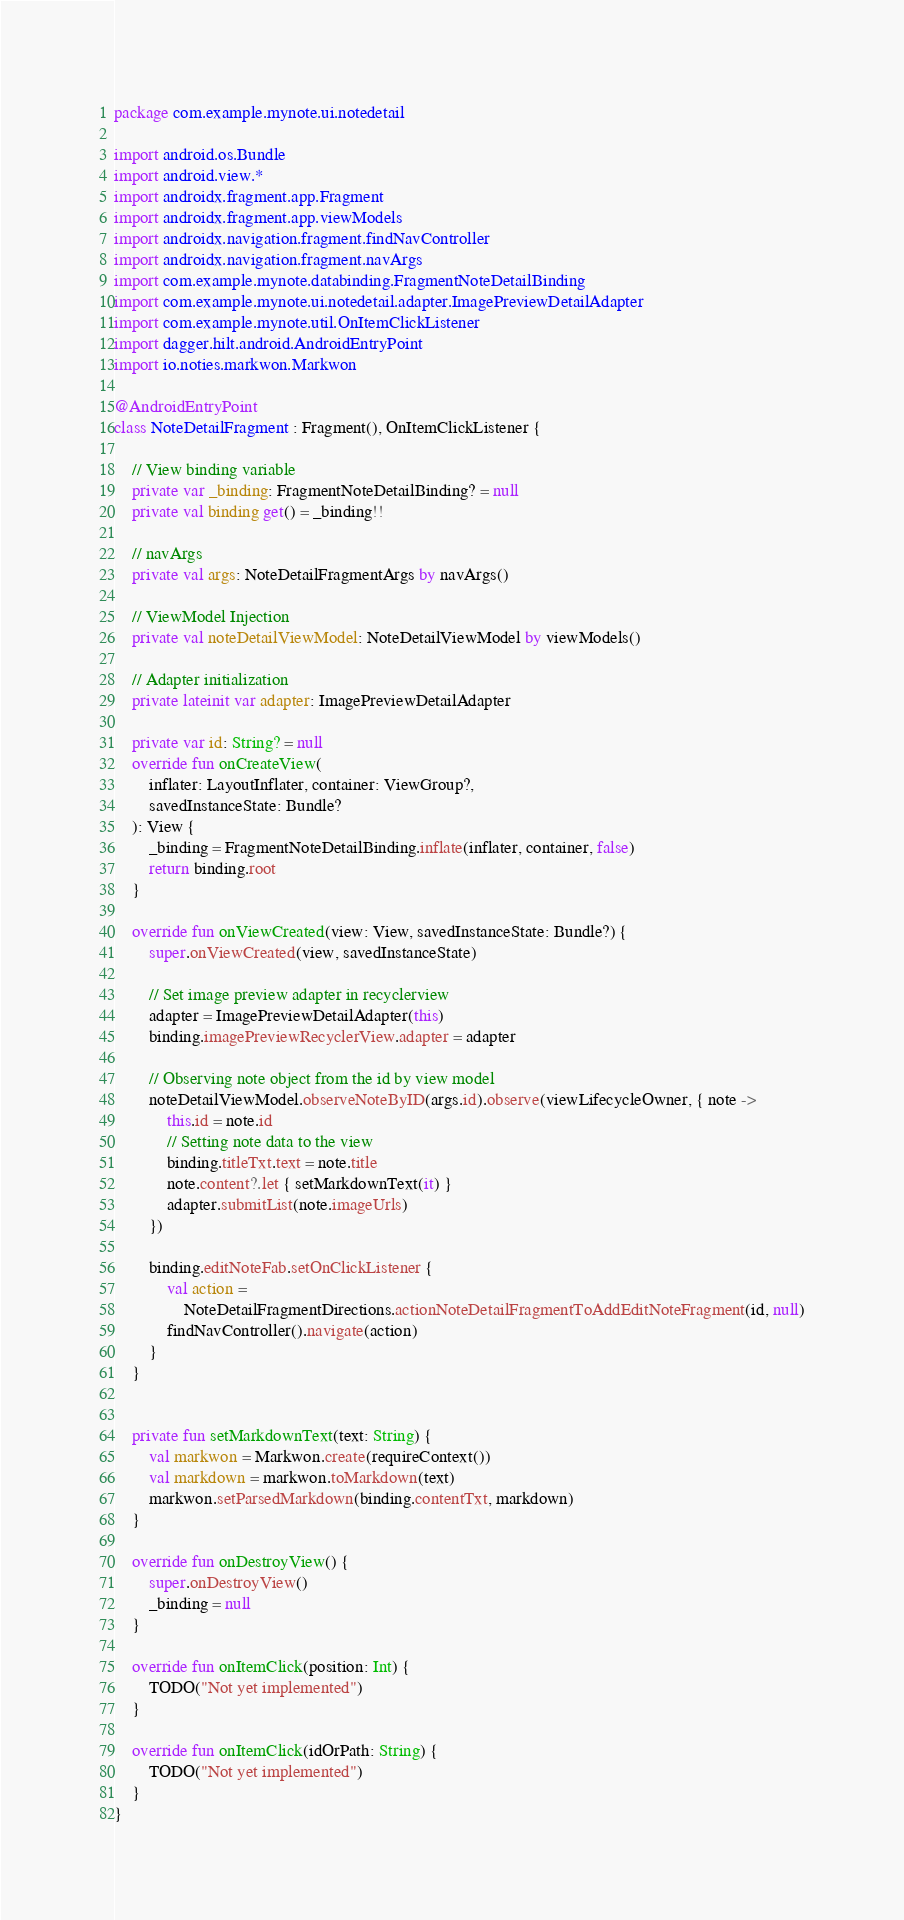<code> <loc_0><loc_0><loc_500><loc_500><_Kotlin_>package com.example.mynote.ui.notedetail

import android.os.Bundle
import android.view.*
import androidx.fragment.app.Fragment
import androidx.fragment.app.viewModels
import androidx.navigation.fragment.findNavController
import androidx.navigation.fragment.navArgs
import com.example.mynote.databinding.FragmentNoteDetailBinding
import com.example.mynote.ui.notedetail.adapter.ImagePreviewDetailAdapter
import com.example.mynote.util.OnItemClickListener
import dagger.hilt.android.AndroidEntryPoint
import io.noties.markwon.Markwon

@AndroidEntryPoint
class NoteDetailFragment : Fragment(), OnItemClickListener {

    // View binding variable
    private var _binding: FragmentNoteDetailBinding? = null
    private val binding get() = _binding!!

    // navArgs
    private val args: NoteDetailFragmentArgs by navArgs()

    // ViewModel Injection
    private val noteDetailViewModel: NoteDetailViewModel by viewModels()

    // Adapter initialization
    private lateinit var adapter: ImagePreviewDetailAdapter

    private var id: String? = null
    override fun onCreateView(
        inflater: LayoutInflater, container: ViewGroup?,
        savedInstanceState: Bundle?
    ): View {
        _binding = FragmentNoteDetailBinding.inflate(inflater, container, false)
        return binding.root
    }

    override fun onViewCreated(view: View, savedInstanceState: Bundle?) {
        super.onViewCreated(view, savedInstanceState)

        // Set image preview adapter in recyclerview
        adapter = ImagePreviewDetailAdapter(this)
        binding.imagePreviewRecyclerView.adapter = adapter

        // Observing note object from the id by view model
        noteDetailViewModel.observeNoteByID(args.id).observe(viewLifecycleOwner, { note ->
            this.id = note.id
            // Setting note data to the view
            binding.titleTxt.text = note.title
            note.content?.let { setMarkdownText(it) }
            adapter.submitList(note.imageUrls)
        })

        binding.editNoteFab.setOnClickListener {
            val action =
                NoteDetailFragmentDirections.actionNoteDetailFragmentToAddEditNoteFragment(id, null)
            findNavController().navigate(action)
        }
    }


    private fun setMarkdownText(text: String) {
        val markwon = Markwon.create(requireContext())
        val markdown = markwon.toMarkdown(text)
        markwon.setParsedMarkdown(binding.contentTxt, markdown)
    }

    override fun onDestroyView() {
        super.onDestroyView()
        _binding = null
    }

    override fun onItemClick(position: Int) {
        TODO("Not yet implemented")
    }

    override fun onItemClick(idOrPath: String) {
        TODO("Not yet implemented")
    }
}</code> 